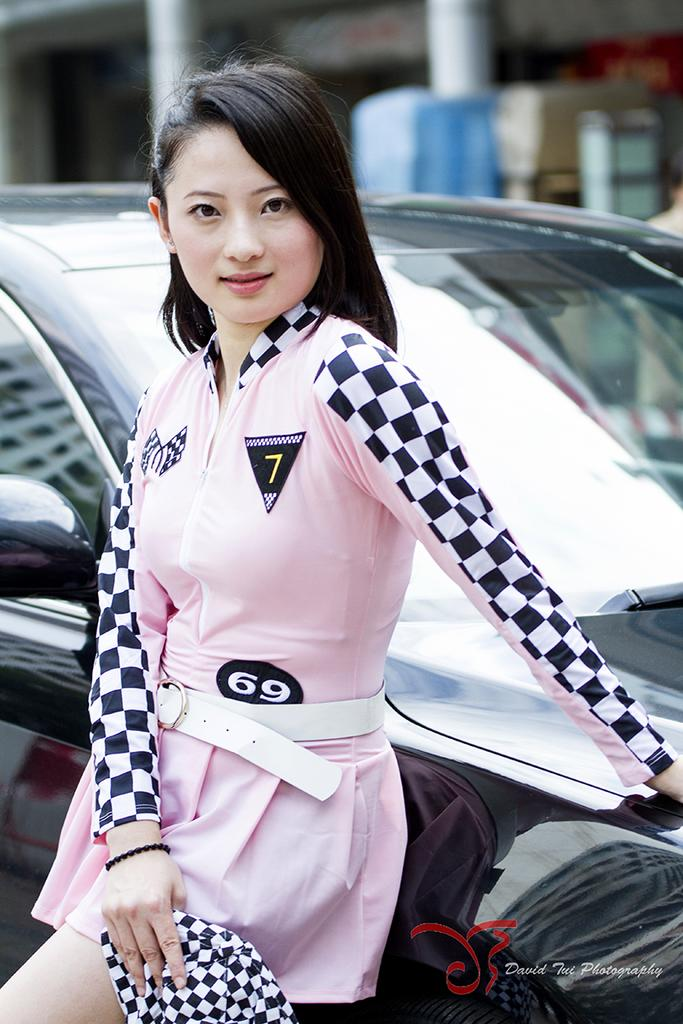What is the main subject of the image? There is a woman standing in the image. What is the woman doing in the image? The woman is leaning on a car. Can you describe the background of the image? The background of the image is not clear, but there are pillars visible. Are there any other objects in the background besides the pillars? Yes, there are other unspecified objects in the background. What type of chair is the woman sitting on in the image? There is no chair present in the image; the woman is leaning on a car. Can you see the sea in the background of the image? There is no sea visible in the image; the background features pillars and other unspecified objects. 